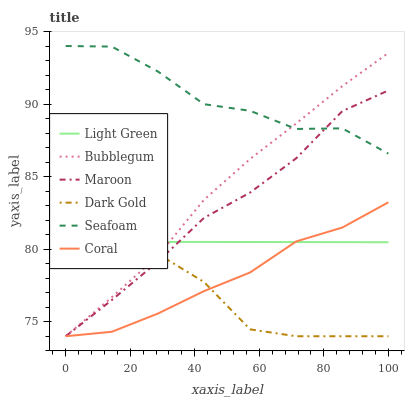Does Dark Gold have the minimum area under the curve?
Answer yes or no. Yes. Does Seafoam have the maximum area under the curve?
Answer yes or no. Yes. Does Coral have the minimum area under the curve?
Answer yes or no. No. Does Coral have the maximum area under the curve?
Answer yes or no. No. Is Light Green the smoothest?
Answer yes or no. Yes. Is Seafoam the roughest?
Answer yes or no. Yes. Is Coral the smoothest?
Answer yes or no. No. Is Coral the roughest?
Answer yes or no. No. Does Dark Gold have the lowest value?
Answer yes or no. Yes. Does Seafoam have the lowest value?
Answer yes or no. No. Does Seafoam have the highest value?
Answer yes or no. Yes. Does Coral have the highest value?
Answer yes or no. No. Is Light Green less than Seafoam?
Answer yes or no. Yes. Is Seafoam greater than Coral?
Answer yes or no. Yes. Does Bubblegum intersect Coral?
Answer yes or no. Yes. Is Bubblegum less than Coral?
Answer yes or no. No. Is Bubblegum greater than Coral?
Answer yes or no. No. Does Light Green intersect Seafoam?
Answer yes or no. No. 